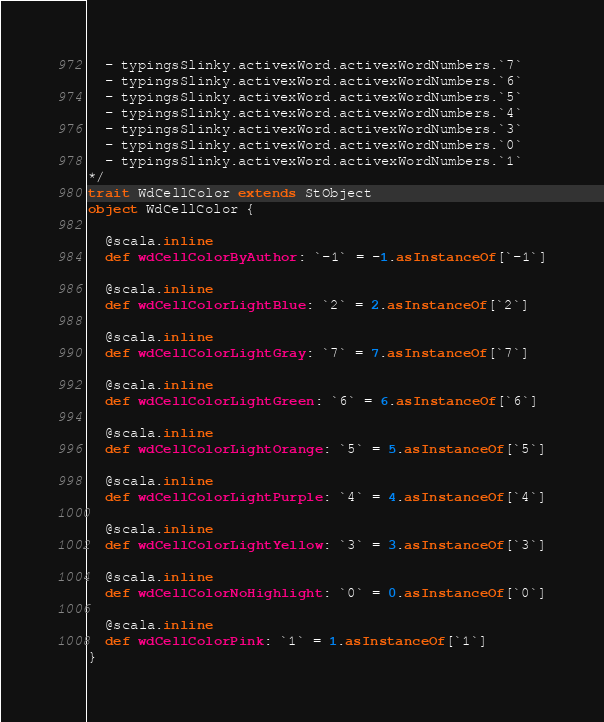<code> <loc_0><loc_0><loc_500><loc_500><_Scala_>  - typingsSlinky.activexWord.activexWordNumbers.`7`
  - typingsSlinky.activexWord.activexWordNumbers.`6`
  - typingsSlinky.activexWord.activexWordNumbers.`5`
  - typingsSlinky.activexWord.activexWordNumbers.`4`
  - typingsSlinky.activexWord.activexWordNumbers.`3`
  - typingsSlinky.activexWord.activexWordNumbers.`0`
  - typingsSlinky.activexWord.activexWordNumbers.`1`
*/
trait WdCellColor extends StObject
object WdCellColor {
  
  @scala.inline
  def wdCellColorByAuthor: `-1` = -1.asInstanceOf[`-1`]
  
  @scala.inline
  def wdCellColorLightBlue: `2` = 2.asInstanceOf[`2`]
  
  @scala.inline
  def wdCellColorLightGray: `7` = 7.asInstanceOf[`7`]
  
  @scala.inline
  def wdCellColorLightGreen: `6` = 6.asInstanceOf[`6`]
  
  @scala.inline
  def wdCellColorLightOrange: `5` = 5.asInstanceOf[`5`]
  
  @scala.inline
  def wdCellColorLightPurple: `4` = 4.asInstanceOf[`4`]
  
  @scala.inline
  def wdCellColorLightYellow: `3` = 3.asInstanceOf[`3`]
  
  @scala.inline
  def wdCellColorNoHighlight: `0` = 0.asInstanceOf[`0`]
  
  @scala.inline
  def wdCellColorPink: `1` = 1.asInstanceOf[`1`]
}
</code> 